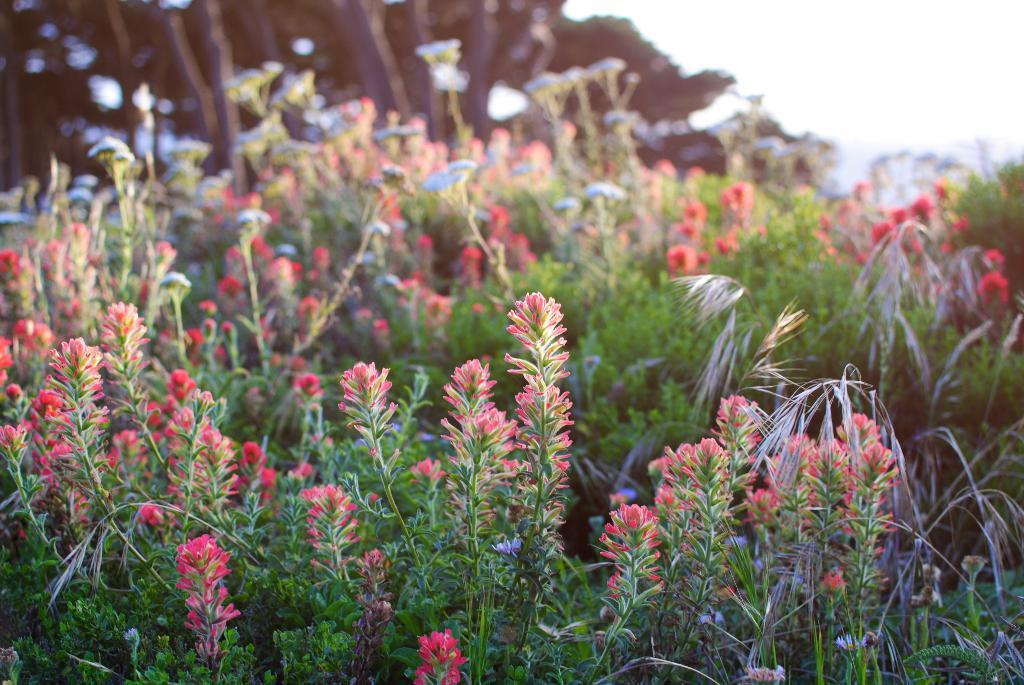What type of plants can be seen in the image? There are plants with flowers in the image. Where are the plants located in the image? The plants are in the middle of the image. What can be seen in the background of the image? There are trees in the background of the image. What is visible at the top of the image? The sky is visible at the top of the image. How many planes are flying in the image? There are no planes visible in the image; it only features plants with flowers, trees, and the sky. What type of bike is being used by the plants in the image? There is no bike present in the image, as it only contains plants, trees, and the sky. 